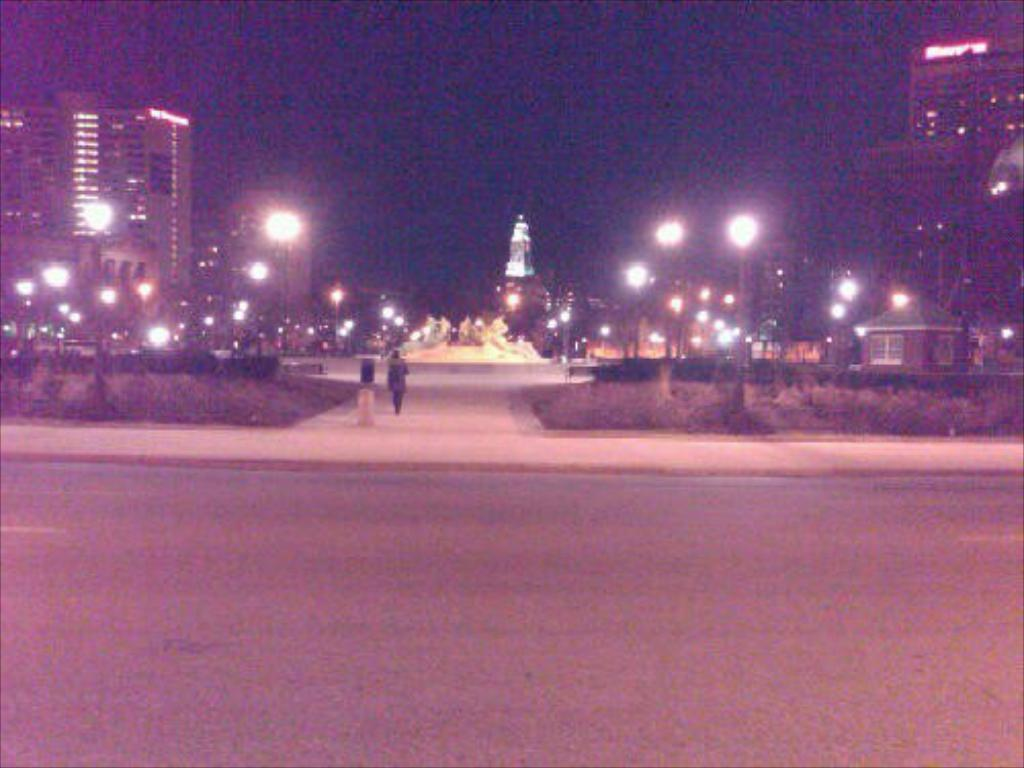When was the image taken? The image was taken at night. What is the person in the image doing? There is a person walking on a path in the image. What other objects or structures can be seen in the image? There is a statue, buildings, street lights, and poles visible in the image. How is the image illuminated? Street lights provide illumination in the image. What is the color of the background in the image? The background of the image is dark. How many frogs are hopping on the person's toe in the image? There are no frogs present in the image, and the person's toe is not visible. What is the height of the statue in the image? The height of the statue cannot be determined from the image alone, as there is no reference point for comparison. 